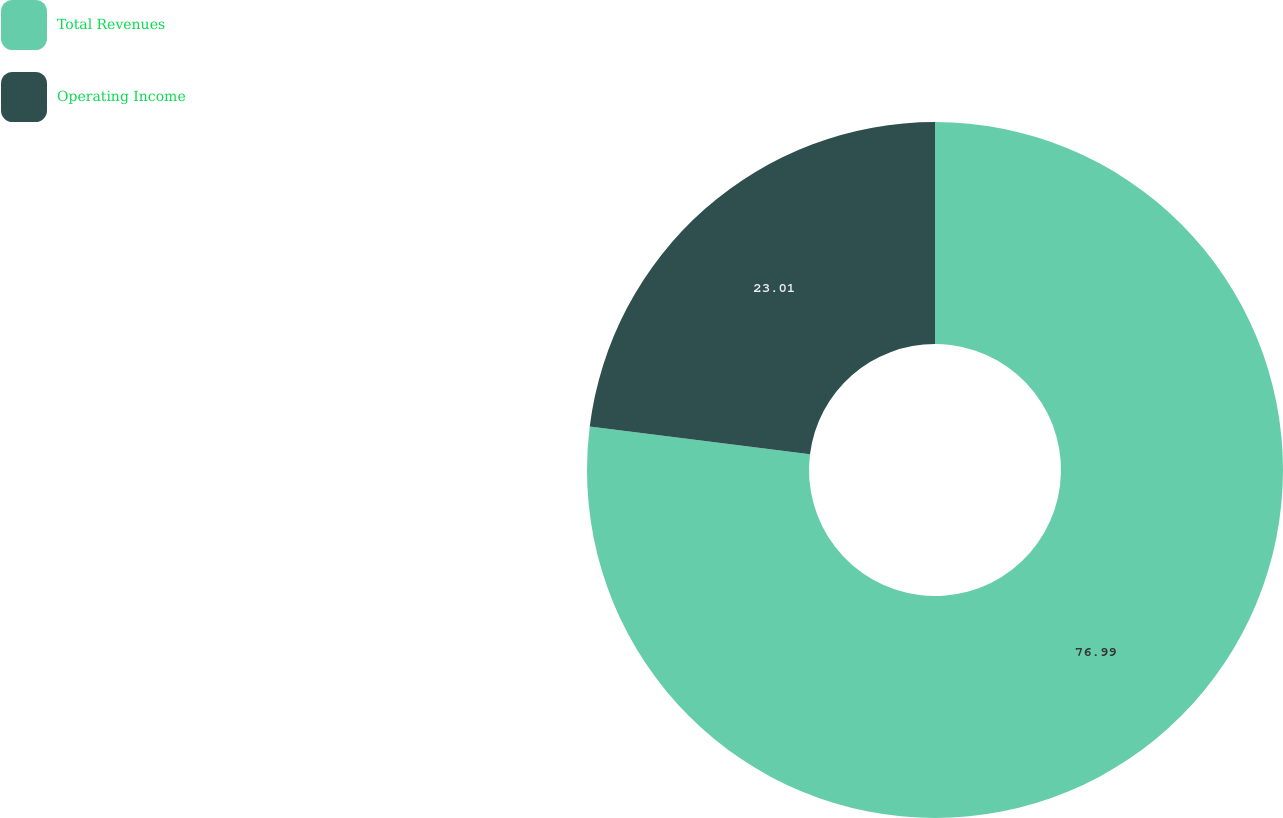Convert chart to OTSL. <chart><loc_0><loc_0><loc_500><loc_500><pie_chart><fcel>Total Revenues<fcel>Operating Income<nl><fcel>76.99%<fcel>23.01%<nl></chart> 